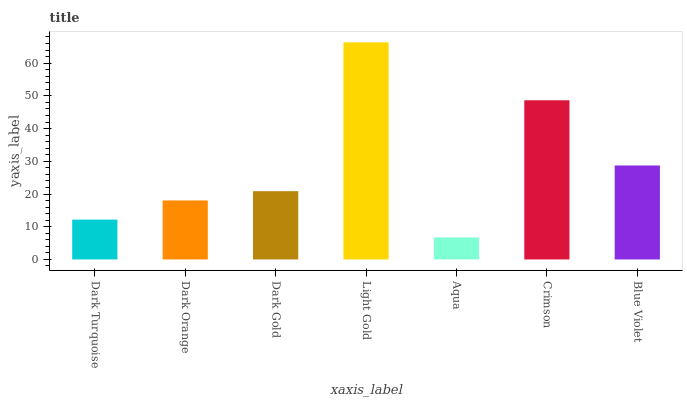Is Dark Orange the minimum?
Answer yes or no. No. Is Dark Orange the maximum?
Answer yes or no. No. Is Dark Orange greater than Dark Turquoise?
Answer yes or no. Yes. Is Dark Turquoise less than Dark Orange?
Answer yes or no. Yes. Is Dark Turquoise greater than Dark Orange?
Answer yes or no. No. Is Dark Orange less than Dark Turquoise?
Answer yes or no. No. Is Dark Gold the high median?
Answer yes or no. Yes. Is Dark Gold the low median?
Answer yes or no. Yes. Is Crimson the high median?
Answer yes or no. No. Is Light Gold the low median?
Answer yes or no. No. 